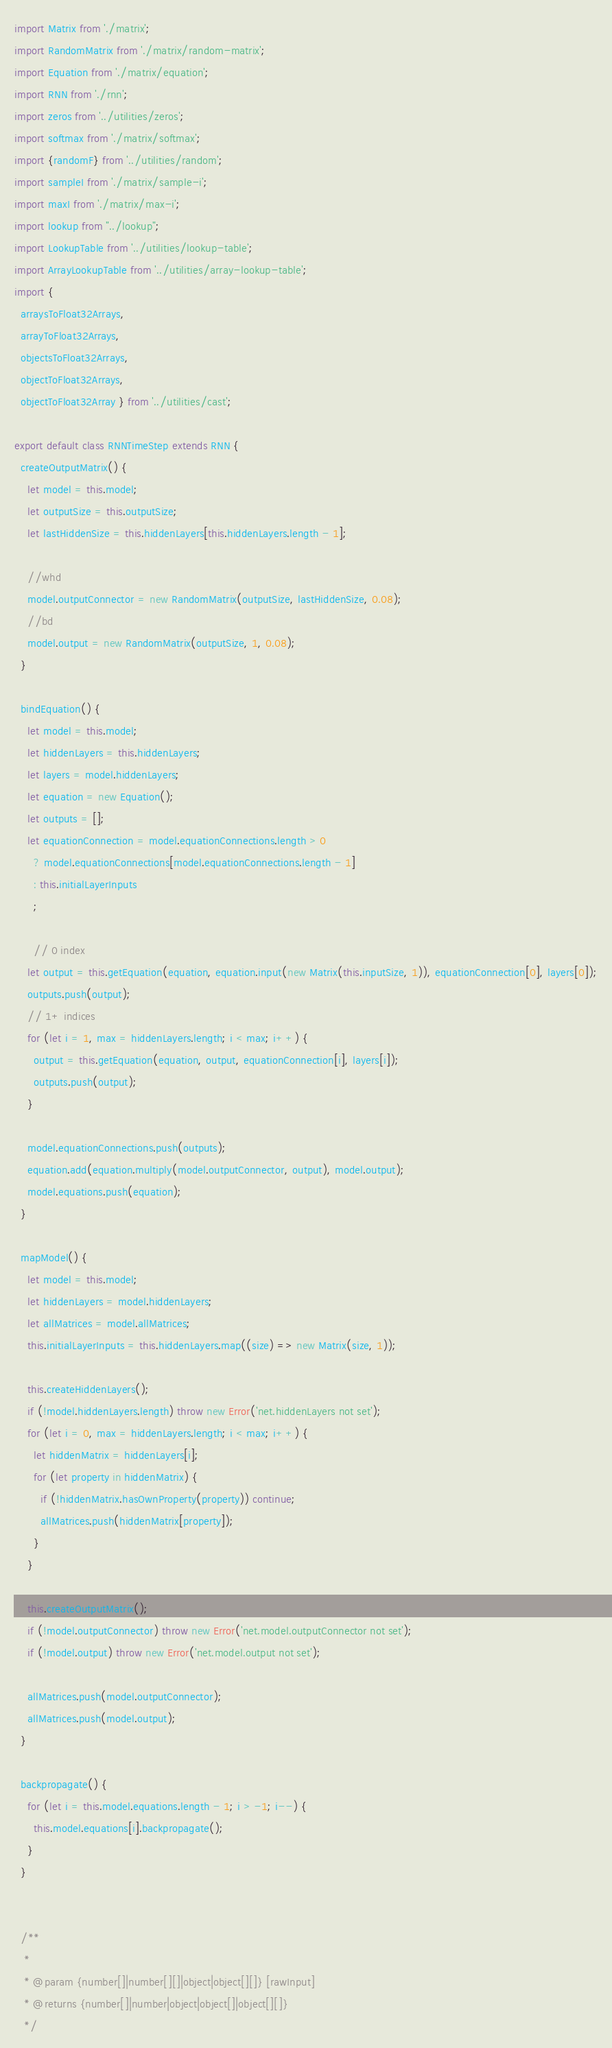<code> <loc_0><loc_0><loc_500><loc_500><_JavaScript_>import Matrix from './matrix';
import RandomMatrix from './matrix/random-matrix';
import Equation from './matrix/equation';
import RNN from './rnn';
import zeros from '../utilities/zeros';
import softmax from './matrix/softmax';
import {randomF} from '../utilities/random';
import sampleI from './matrix/sample-i';
import maxI from './matrix/max-i';
import lookup from "../lookup";
import LookupTable from '../utilities/lookup-table';
import ArrayLookupTable from '../utilities/array-lookup-table';
import {
  arraysToFloat32Arrays,
  arrayToFloat32Arrays,
  objectsToFloat32Arrays,
  objectToFloat32Arrays,
  objectToFloat32Array } from '../utilities/cast';

export default class RNNTimeStep extends RNN {
  createOutputMatrix() {
    let model = this.model;
    let outputSize = this.outputSize;
    let lastHiddenSize = this.hiddenLayers[this.hiddenLayers.length - 1];

    //whd
    model.outputConnector = new RandomMatrix(outputSize, lastHiddenSize, 0.08);
    //bd
    model.output = new RandomMatrix(outputSize, 1, 0.08);
  }

  bindEquation() {
    let model = this.model;
    let hiddenLayers = this.hiddenLayers;
    let layers = model.hiddenLayers;
    let equation = new Equation();
    let outputs = [];
    let equationConnection = model.equationConnections.length > 0
      ? model.equationConnections[model.equationConnections.length - 1]
      : this.initialLayerInputs
      ;

      // 0 index
    let output = this.getEquation(equation, equation.input(new Matrix(this.inputSize, 1)), equationConnection[0], layers[0]);
    outputs.push(output);
    // 1+ indices
    for (let i = 1, max = hiddenLayers.length; i < max; i++) {
      output = this.getEquation(equation, output, equationConnection[i], layers[i]);
      outputs.push(output);
    }

    model.equationConnections.push(outputs);
    equation.add(equation.multiply(model.outputConnector, output), model.output);
    model.equations.push(equation);
  }

  mapModel() {
    let model = this.model;
    let hiddenLayers = model.hiddenLayers;
    let allMatrices = model.allMatrices;
    this.initialLayerInputs = this.hiddenLayers.map((size) => new Matrix(size, 1));

    this.createHiddenLayers();
    if (!model.hiddenLayers.length) throw new Error('net.hiddenLayers not set');
    for (let i = 0, max = hiddenLayers.length; i < max; i++) {
      let hiddenMatrix = hiddenLayers[i];
      for (let property in hiddenMatrix) {
        if (!hiddenMatrix.hasOwnProperty(property)) continue;
        allMatrices.push(hiddenMatrix[property]);
      }
    }

    this.createOutputMatrix();
    if (!model.outputConnector) throw new Error('net.model.outputConnector not set');
    if (!model.output) throw new Error('net.model.output not set');

    allMatrices.push(model.outputConnector);
    allMatrices.push(model.output);
  }

  backpropagate() {
    for (let i = this.model.equations.length - 1; i > -1; i--) {
      this.model.equations[i].backpropagate();
    }
  }


  /**
   *
   * @param {number[]|number[][]|object|object[][]} [rawInput]
   * @returns {number[]|number|object|object[]|object[][]}
   */</code> 